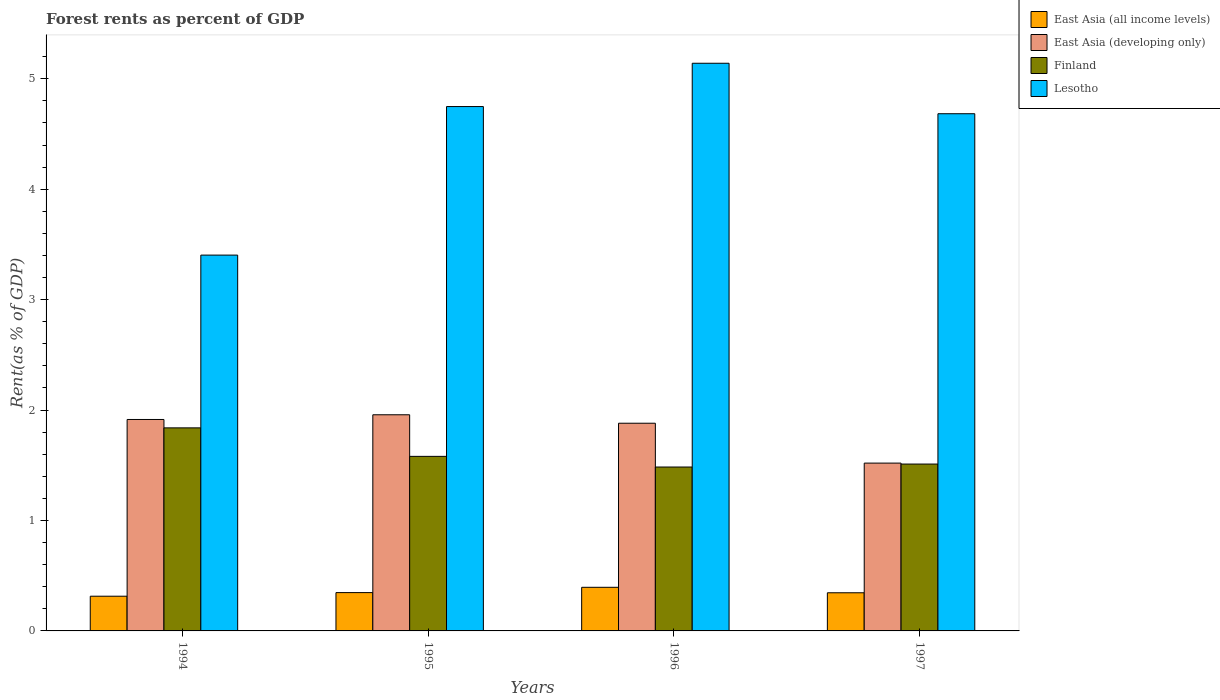How many different coloured bars are there?
Offer a very short reply. 4. How many groups of bars are there?
Give a very brief answer. 4. Are the number of bars per tick equal to the number of legend labels?
Make the answer very short. Yes. How many bars are there on the 4th tick from the right?
Your answer should be compact. 4. What is the label of the 1st group of bars from the left?
Your response must be concise. 1994. What is the forest rent in Finland in 1995?
Provide a succinct answer. 1.58. Across all years, what is the maximum forest rent in Lesotho?
Give a very brief answer. 5.14. Across all years, what is the minimum forest rent in East Asia (all income levels)?
Your response must be concise. 0.31. In which year was the forest rent in East Asia (developing only) minimum?
Keep it short and to the point. 1997. What is the total forest rent in Finland in the graph?
Ensure brevity in your answer.  6.42. What is the difference between the forest rent in East Asia (developing only) in 1994 and that in 1997?
Offer a terse response. 0.4. What is the difference between the forest rent in Finland in 1997 and the forest rent in East Asia (developing only) in 1995?
Give a very brief answer. -0.45. What is the average forest rent in East Asia (developing only) per year?
Your answer should be very brief. 1.82. In the year 1997, what is the difference between the forest rent in Lesotho and forest rent in East Asia (all income levels)?
Offer a terse response. 4.34. In how many years, is the forest rent in Lesotho greater than 4.2 %?
Offer a very short reply. 3. What is the ratio of the forest rent in Lesotho in 1994 to that in 1995?
Offer a terse response. 0.72. Is the forest rent in Finland in 1994 less than that in 1995?
Your answer should be very brief. No. Is the difference between the forest rent in Lesotho in 1994 and 1996 greater than the difference between the forest rent in East Asia (all income levels) in 1994 and 1996?
Your response must be concise. No. What is the difference between the highest and the second highest forest rent in Lesotho?
Offer a terse response. 0.39. What is the difference between the highest and the lowest forest rent in Lesotho?
Your answer should be compact. 1.74. In how many years, is the forest rent in Lesotho greater than the average forest rent in Lesotho taken over all years?
Offer a terse response. 3. Is the sum of the forest rent in East Asia (developing only) in 1994 and 1996 greater than the maximum forest rent in Lesotho across all years?
Offer a very short reply. No. What does the 1st bar from the left in 1994 represents?
Make the answer very short. East Asia (all income levels). What does the 1st bar from the right in 1994 represents?
Your response must be concise. Lesotho. Are all the bars in the graph horizontal?
Offer a terse response. No. How many years are there in the graph?
Offer a very short reply. 4. Are the values on the major ticks of Y-axis written in scientific E-notation?
Offer a very short reply. No. How are the legend labels stacked?
Provide a succinct answer. Vertical. What is the title of the graph?
Your answer should be compact. Forest rents as percent of GDP. Does "Italy" appear as one of the legend labels in the graph?
Your answer should be compact. No. What is the label or title of the Y-axis?
Provide a succinct answer. Rent(as % of GDP). What is the Rent(as % of GDP) in East Asia (all income levels) in 1994?
Give a very brief answer. 0.31. What is the Rent(as % of GDP) in East Asia (developing only) in 1994?
Make the answer very short. 1.91. What is the Rent(as % of GDP) in Finland in 1994?
Make the answer very short. 1.84. What is the Rent(as % of GDP) in Lesotho in 1994?
Offer a terse response. 3.4. What is the Rent(as % of GDP) in East Asia (all income levels) in 1995?
Your response must be concise. 0.35. What is the Rent(as % of GDP) in East Asia (developing only) in 1995?
Ensure brevity in your answer.  1.96. What is the Rent(as % of GDP) of Finland in 1995?
Make the answer very short. 1.58. What is the Rent(as % of GDP) in Lesotho in 1995?
Offer a terse response. 4.75. What is the Rent(as % of GDP) of East Asia (all income levels) in 1996?
Keep it short and to the point. 0.4. What is the Rent(as % of GDP) of East Asia (developing only) in 1996?
Ensure brevity in your answer.  1.88. What is the Rent(as % of GDP) in Finland in 1996?
Your response must be concise. 1.48. What is the Rent(as % of GDP) in Lesotho in 1996?
Your answer should be very brief. 5.14. What is the Rent(as % of GDP) in East Asia (all income levels) in 1997?
Offer a very short reply. 0.35. What is the Rent(as % of GDP) in East Asia (developing only) in 1997?
Ensure brevity in your answer.  1.52. What is the Rent(as % of GDP) in Finland in 1997?
Provide a succinct answer. 1.51. What is the Rent(as % of GDP) in Lesotho in 1997?
Offer a very short reply. 4.68. Across all years, what is the maximum Rent(as % of GDP) in East Asia (all income levels)?
Your answer should be compact. 0.4. Across all years, what is the maximum Rent(as % of GDP) of East Asia (developing only)?
Ensure brevity in your answer.  1.96. Across all years, what is the maximum Rent(as % of GDP) in Finland?
Ensure brevity in your answer.  1.84. Across all years, what is the maximum Rent(as % of GDP) in Lesotho?
Ensure brevity in your answer.  5.14. Across all years, what is the minimum Rent(as % of GDP) of East Asia (all income levels)?
Provide a succinct answer. 0.31. Across all years, what is the minimum Rent(as % of GDP) in East Asia (developing only)?
Offer a terse response. 1.52. Across all years, what is the minimum Rent(as % of GDP) in Finland?
Your answer should be compact. 1.48. Across all years, what is the minimum Rent(as % of GDP) of Lesotho?
Give a very brief answer. 3.4. What is the total Rent(as % of GDP) in East Asia (all income levels) in the graph?
Your response must be concise. 1.4. What is the total Rent(as % of GDP) in East Asia (developing only) in the graph?
Keep it short and to the point. 7.27. What is the total Rent(as % of GDP) in Finland in the graph?
Keep it short and to the point. 6.42. What is the total Rent(as % of GDP) in Lesotho in the graph?
Provide a succinct answer. 17.98. What is the difference between the Rent(as % of GDP) of East Asia (all income levels) in 1994 and that in 1995?
Ensure brevity in your answer.  -0.03. What is the difference between the Rent(as % of GDP) of East Asia (developing only) in 1994 and that in 1995?
Offer a terse response. -0.04. What is the difference between the Rent(as % of GDP) in Finland in 1994 and that in 1995?
Your response must be concise. 0.26. What is the difference between the Rent(as % of GDP) in Lesotho in 1994 and that in 1995?
Your answer should be very brief. -1.35. What is the difference between the Rent(as % of GDP) in East Asia (all income levels) in 1994 and that in 1996?
Your response must be concise. -0.08. What is the difference between the Rent(as % of GDP) in East Asia (developing only) in 1994 and that in 1996?
Your response must be concise. 0.03. What is the difference between the Rent(as % of GDP) in Finland in 1994 and that in 1996?
Offer a terse response. 0.35. What is the difference between the Rent(as % of GDP) in Lesotho in 1994 and that in 1996?
Provide a succinct answer. -1.74. What is the difference between the Rent(as % of GDP) in East Asia (all income levels) in 1994 and that in 1997?
Offer a very short reply. -0.03. What is the difference between the Rent(as % of GDP) in East Asia (developing only) in 1994 and that in 1997?
Offer a very short reply. 0.4. What is the difference between the Rent(as % of GDP) of Finland in 1994 and that in 1997?
Provide a short and direct response. 0.33. What is the difference between the Rent(as % of GDP) of Lesotho in 1994 and that in 1997?
Provide a succinct answer. -1.28. What is the difference between the Rent(as % of GDP) of East Asia (all income levels) in 1995 and that in 1996?
Offer a very short reply. -0.05. What is the difference between the Rent(as % of GDP) in East Asia (developing only) in 1995 and that in 1996?
Give a very brief answer. 0.08. What is the difference between the Rent(as % of GDP) in Finland in 1995 and that in 1996?
Provide a succinct answer. 0.1. What is the difference between the Rent(as % of GDP) of Lesotho in 1995 and that in 1996?
Offer a terse response. -0.39. What is the difference between the Rent(as % of GDP) in East Asia (all income levels) in 1995 and that in 1997?
Ensure brevity in your answer.  0. What is the difference between the Rent(as % of GDP) of East Asia (developing only) in 1995 and that in 1997?
Provide a short and direct response. 0.44. What is the difference between the Rent(as % of GDP) of Finland in 1995 and that in 1997?
Your answer should be compact. 0.07. What is the difference between the Rent(as % of GDP) in Lesotho in 1995 and that in 1997?
Your answer should be very brief. 0.07. What is the difference between the Rent(as % of GDP) in East Asia (all income levels) in 1996 and that in 1997?
Ensure brevity in your answer.  0.05. What is the difference between the Rent(as % of GDP) of East Asia (developing only) in 1996 and that in 1997?
Offer a very short reply. 0.36. What is the difference between the Rent(as % of GDP) of Finland in 1996 and that in 1997?
Provide a short and direct response. -0.03. What is the difference between the Rent(as % of GDP) in Lesotho in 1996 and that in 1997?
Offer a very short reply. 0.46. What is the difference between the Rent(as % of GDP) of East Asia (all income levels) in 1994 and the Rent(as % of GDP) of East Asia (developing only) in 1995?
Make the answer very short. -1.64. What is the difference between the Rent(as % of GDP) of East Asia (all income levels) in 1994 and the Rent(as % of GDP) of Finland in 1995?
Offer a terse response. -1.27. What is the difference between the Rent(as % of GDP) of East Asia (all income levels) in 1994 and the Rent(as % of GDP) of Lesotho in 1995?
Offer a very short reply. -4.43. What is the difference between the Rent(as % of GDP) of East Asia (developing only) in 1994 and the Rent(as % of GDP) of Finland in 1995?
Your answer should be very brief. 0.33. What is the difference between the Rent(as % of GDP) in East Asia (developing only) in 1994 and the Rent(as % of GDP) in Lesotho in 1995?
Provide a short and direct response. -2.83. What is the difference between the Rent(as % of GDP) of Finland in 1994 and the Rent(as % of GDP) of Lesotho in 1995?
Provide a succinct answer. -2.91. What is the difference between the Rent(as % of GDP) in East Asia (all income levels) in 1994 and the Rent(as % of GDP) in East Asia (developing only) in 1996?
Keep it short and to the point. -1.57. What is the difference between the Rent(as % of GDP) in East Asia (all income levels) in 1994 and the Rent(as % of GDP) in Finland in 1996?
Your answer should be very brief. -1.17. What is the difference between the Rent(as % of GDP) of East Asia (all income levels) in 1994 and the Rent(as % of GDP) of Lesotho in 1996?
Make the answer very short. -4.83. What is the difference between the Rent(as % of GDP) of East Asia (developing only) in 1994 and the Rent(as % of GDP) of Finland in 1996?
Give a very brief answer. 0.43. What is the difference between the Rent(as % of GDP) in East Asia (developing only) in 1994 and the Rent(as % of GDP) in Lesotho in 1996?
Keep it short and to the point. -3.23. What is the difference between the Rent(as % of GDP) of Finland in 1994 and the Rent(as % of GDP) of Lesotho in 1996?
Your answer should be very brief. -3.3. What is the difference between the Rent(as % of GDP) of East Asia (all income levels) in 1994 and the Rent(as % of GDP) of East Asia (developing only) in 1997?
Your answer should be very brief. -1.21. What is the difference between the Rent(as % of GDP) of East Asia (all income levels) in 1994 and the Rent(as % of GDP) of Finland in 1997?
Your response must be concise. -1.2. What is the difference between the Rent(as % of GDP) of East Asia (all income levels) in 1994 and the Rent(as % of GDP) of Lesotho in 1997?
Provide a succinct answer. -4.37. What is the difference between the Rent(as % of GDP) of East Asia (developing only) in 1994 and the Rent(as % of GDP) of Finland in 1997?
Offer a terse response. 0.4. What is the difference between the Rent(as % of GDP) in East Asia (developing only) in 1994 and the Rent(as % of GDP) in Lesotho in 1997?
Ensure brevity in your answer.  -2.77. What is the difference between the Rent(as % of GDP) of Finland in 1994 and the Rent(as % of GDP) of Lesotho in 1997?
Ensure brevity in your answer.  -2.84. What is the difference between the Rent(as % of GDP) in East Asia (all income levels) in 1995 and the Rent(as % of GDP) in East Asia (developing only) in 1996?
Give a very brief answer. -1.53. What is the difference between the Rent(as % of GDP) of East Asia (all income levels) in 1995 and the Rent(as % of GDP) of Finland in 1996?
Your response must be concise. -1.14. What is the difference between the Rent(as % of GDP) in East Asia (all income levels) in 1995 and the Rent(as % of GDP) in Lesotho in 1996?
Provide a short and direct response. -4.79. What is the difference between the Rent(as % of GDP) in East Asia (developing only) in 1995 and the Rent(as % of GDP) in Finland in 1996?
Offer a very short reply. 0.47. What is the difference between the Rent(as % of GDP) of East Asia (developing only) in 1995 and the Rent(as % of GDP) of Lesotho in 1996?
Give a very brief answer. -3.18. What is the difference between the Rent(as % of GDP) in Finland in 1995 and the Rent(as % of GDP) in Lesotho in 1996?
Offer a terse response. -3.56. What is the difference between the Rent(as % of GDP) in East Asia (all income levels) in 1995 and the Rent(as % of GDP) in East Asia (developing only) in 1997?
Give a very brief answer. -1.17. What is the difference between the Rent(as % of GDP) of East Asia (all income levels) in 1995 and the Rent(as % of GDP) of Finland in 1997?
Your answer should be compact. -1.16. What is the difference between the Rent(as % of GDP) of East Asia (all income levels) in 1995 and the Rent(as % of GDP) of Lesotho in 1997?
Provide a short and direct response. -4.34. What is the difference between the Rent(as % of GDP) of East Asia (developing only) in 1995 and the Rent(as % of GDP) of Finland in 1997?
Make the answer very short. 0.45. What is the difference between the Rent(as % of GDP) of East Asia (developing only) in 1995 and the Rent(as % of GDP) of Lesotho in 1997?
Offer a very short reply. -2.73. What is the difference between the Rent(as % of GDP) in Finland in 1995 and the Rent(as % of GDP) in Lesotho in 1997?
Offer a very short reply. -3.1. What is the difference between the Rent(as % of GDP) in East Asia (all income levels) in 1996 and the Rent(as % of GDP) in East Asia (developing only) in 1997?
Ensure brevity in your answer.  -1.12. What is the difference between the Rent(as % of GDP) of East Asia (all income levels) in 1996 and the Rent(as % of GDP) of Finland in 1997?
Keep it short and to the point. -1.12. What is the difference between the Rent(as % of GDP) of East Asia (all income levels) in 1996 and the Rent(as % of GDP) of Lesotho in 1997?
Ensure brevity in your answer.  -4.29. What is the difference between the Rent(as % of GDP) of East Asia (developing only) in 1996 and the Rent(as % of GDP) of Finland in 1997?
Your answer should be very brief. 0.37. What is the difference between the Rent(as % of GDP) in East Asia (developing only) in 1996 and the Rent(as % of GDP) in Lesotho in 1997?
Ensure brevity in your answer.  -2.8. What is the difference between the Rent(as % of GDP) in Finland in 1996 and the Rent(as % of GDP) in Lesotho in 1997?
Your answer should be very brief. -3.2. What is the average Rent(as % of GDP) in East Asia (all income levels) per year?
Give a very brief answer. 0.35. What is the average Rent(as % of GDP) of East Asia (developing only) per year?
Your answer should be very brief. 1.82. What is the average Rent(as % of GDP) of Finland per year?
Give a very brief answer. 1.6. What is the average Rent(as % of GDP) in Lesotho per year?
Give a very brief answer. 4.49. In the year 1994, what is the difference between the Rent(as % of GDP) of East Asia (all income levels) and Rent(as % of GDP) of East Asia (developing only)?
Keep it short and to the point. -1.6. In the year 1994, what is the difference between the Rent(as % of GDP) of East Asia (all income levels) and Rent(as % of GDP) of Finland?
Provide a succinct answer. -1.52. In the year 1994, what is the difference between the Rent(as % of GDP) of East Asia (all income levels) and Rent(as % of GDP) of Lesotho?
Your answer should be compact. -3.09. In the year 1994, what is the difference between the Rent(as % of GDP) of East Asia (developing only) and Rent(as % of GDP) of Finland?
Offer a very short reply. 0.08. In the year 1994, what is the difference between the Rent(as % of GDP) of East Asia (developing only) and Rent(as % of GDP) of Lesotho?
Offer a very short reply. -1.49. In the year 1994, what is the difference between the Rent(as % of GDP) in Finland and Rent(as % of GDP) in Lesotho?
Make the answer very short. -1.56. In the year 1995, what is the difference between the Rent(as % of GDP) of East Asia (all income levels) and Rent(as % of GDP) of East Asia (developing only)?
Offer a very short reply. -1.61. In the year 1995, what is the difference between the Rent(as % of GDP) in East Asia (all income levels) and Rent(as % of GDP) in Finland?
Keep it short and to the point. -1.23. In the year 1995, what is the difference between the Rent(as % of GDP) in East Asia (all income levels) and Rent(as % of GDP) in Lesotho?
Ensure brevity in your answer.  -4.4. In the year 1995, what is the difference between the Rent(as % of GDP) in East Asia (developing only) and Rent(as % of GDP) in Finland?
Keep it short and to the point. 0.38. In the year 1995, what is the difference between the Rent(as % of GDP) in East Asia (developing only) and Rent(as % of GDP) in Lesotho?
Provide a short and direct response. -2.79. In the year 1995, what is the difference between the Rent(as % of GDP) of Finland and Rent(as % of GDP) of Lesotho?
Your response must be concise. -3.17. In the year 1996, what is the difference between the Rent(as % of GDP) in East Asia (all income levels) and Rent(as % of GDP) in East Asia (developing only)?
Make the answer very short. -1.49. In the year 1996, what is the difference between the Rent(as % of GDP) in East Asia (all income levels) and Rent(as % of GDP) in Finland?
Give a very brief answer. -1.09. In the year 1996, what is the difference between the Rent(as % of GDP) of East Asia (all income levels) and Rent(as % of GDP) of Lesotho?
Offer a terse response. -4.75. In the year 1996, what is the difference between the Rent(as % of GDP) of East Asia (developing only) and Rent(as % of GDP) of Finland?
Offer a very short reply. 0.4. In the year 1996, what is the difference between the Rent(as % of GDP) in East Asia (developing only) and Rent(as % of GDP) in Lesotho?
Offer a terse response. -3.26. In the year 1996, what is the difference between the Rent(as % of GDP) in Finland and Rent(as % of GDP) in Lesotho?
Make the answer very short. -3.66. In the year 1997, what is the difference between the Rent(as % of GDP) of East Asia (all income levels) and Rent(as % of GDP) of East Asia (developing only)?
Your answer should be very brief. -1.17. In the year 1997, what is the difference between the Rent(as % of GDP) in East Asia (all income levels) and Rent(as % of GDP) in Finland?
Your response must be concise. -1.17. In the year 1997, what is the difference between the Rent(as % of GDP) in East Asia (all income levels) and Rent(as % of GDP) in Lesotho?
Give a very brief answer. -4.34. In the year 1997, what is the difference between the Rent(as % of GDP) in East Asia (developing only) and Rent(as % of GDP) in Finland?
Keep it short and to the point. 0.01. In the year 1997, what is the difference between the Rent(as % of GDP) in East Asia (developing only) and Rent(as % of GDP) in Lesotho?
Provide a succinct answer. -3.16. In the year 1997, what is the difference between the Rent(as % of GDP) of Finland and Rent(as % of GDP) of Lesotho?
Provide a succinct answer. -3.17. What is the ratio of the Rent(as % of GDP) of East Asia (all income levels) in 1994 to that in 1995?
Keep it short and to the point. 0.91. What is the ratio of the Rent(as % of GDP) of East Asia (developing only) in 1994 to that in 1995?
Your answer should be very brief. 0.98. What is the ratio of the Rent(as % of GDP) in Finland in 1994 to that in 1995?
Provide a succinct answer. 1.16. What is the ratio of the Rent(as % of GDP) of Lesotho in 1994 to that in 1995?
Give a very brief answer. 0.72. What is the ratio of the Rent(as % of GDP) in East Asia (all income levels) in 1994 to that in 1996?
Ensure brevity in your answer.  0.8. What is the ratio of the Rent(as % of GDP) in East Asia (developing only) in 1994 to that in 1996?
Make the answer very short. 1.02. What is the ratio of the Rent(as % of GDP) of Finland in 1994 to that in 1996?
Your response must be concise. 1.24. What is the ratio of the Rent(as % of GDP) of Lesotho in 1994 to that in 1996?
Your answer should be very brief. 0.66. What is the ratio of the Rent(as % of GDP) of East Asia (all income levels) in 1994 to that in 1997?
Provide a succinct answer. 0.91. What is the ratio of the Rent(as % of GDP) in East Asia (developing only) in 1994 to that in 1997?
Provide a succinct answer. 1.26. What is the ratio of the Rent(as % of GDP) in Finland in 1994 to that in 1997?
Your answer should be compact. 1.22. What is the ratio of the Rent(as % of GDP) of Lesotho in 1994 to that in 1997?
Provide a short and direct response. 0.73. What is the ratio of the Rent(as % of GDP) in East Asia (all income levels) in 1995 to that in 1996?
Keep it short and to the point. 0.88. What is the ratio of the Rent(as % of GDP) of East Asia (developing only) in 1995 to that in 1996?
Your response must be concise. 1.04. What is the ratio of the Rent(as % of GDP) of Finland in 1995 to that in 1996?
Your answer should be compact. 1.06. What is the ratio of the Rent(as % of GDP) of Lesotho in 1995 to that in 1996?
Your answer should be compact. 0.92. What is the ratio of the Rent(as % of GDP) in East Asia (all income levels) in 1995 to that in 1997?
Give a very brief answer. 1. What is the ratio of the Rent(as % of GDP) of East Asia (developing only) in 1995 to that in 1997?
Provide a succinct answer. 1.29. What is the ratio of the Rent(as % of GDP) of Finland in 1995 to that in 1997?
Offer a terse response. 1.05. What is the ratio of the Rent(as % of GDP) in Lesotho in 1995 to that in 1997?
Your response must be concise. 1.01. What is the ratio of the Rent(as % of GDP) in East Asia (all income levels) in 1996 to that in 1997?
Provide a short and direct response. 1.14. What is the ratio of the Rent(as % of GDP) in East Asia (developing only) in 1996 to that in 1997?
Provide a short and direct response. 1.24. What is the ratio of the Rent(as % of GDP) of Finland in 1996 to that in 1997?
Provide a short and direct response. 0.98. What is the ratio of the Rent(as % of GDP) of Lesotho in 1996 to that in 1997?
Provide a short and direct response. 1.1. What is the difference between the highest and the second highest Rent(as % of GDP) of East Asia (all income levels)?
Your response must be concise. 0.05. What is the difference between the highest and the second highest Rent(as % of GDP) of East Asia (developing only)?
Your answer should be compact. 0.04. What is the difference between the highest and the second highest Rent(as % of GDP) of Finland?
Provide a short and direct response. 0.26. What is the difference between the highest and the second highest Rent(as % of GDP) of Lesotho?
Your answer should be very brief. 0.39. What is the difference between the highest and the lowest Rent(as % of GDP) in East Asia (all income levels)?
Make the answer very short. 0.08. What is the difference between the highest and the lowest Rent(as % of GDP) in East Asia (developing only)?
Offer a very short reply. 0.44. What is the difference between the highest and the lowest Rent(as % of GDP) in Finland?
Keep it short and to the point. 0.35. What is the difference between the highest and the lowest Rent(as % of GDP) of Lesotho?
Your response must be concise. 1.74. 